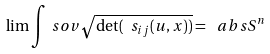<formula> <loc_0><loc_0><loc_500><loc_500>\lim \int _ { \ } s o v \sqrt { \det ( \ s _ { i j } ( u , x ) ) } = \ a b s { S ^ { n } }</formula> 